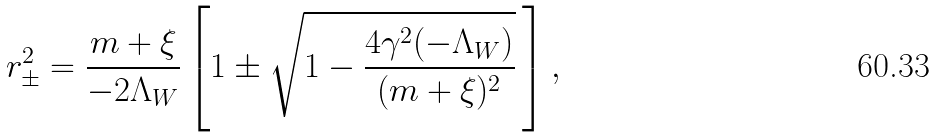<formula> <loc_0><loc_0><loc_500><loc_500>r _ { \pm } ^ { 2 } = \frac { m + \xi } { - 2 \Lambda _ { W } } \left [ 1 \pm \sqrt { 1 - \frac { 4 \gamma ^ { 2 } ( - \Lambda _ { W } ) } { ( m + \xi ) ^ { 2 } } } \, \right ] ,</formula> 